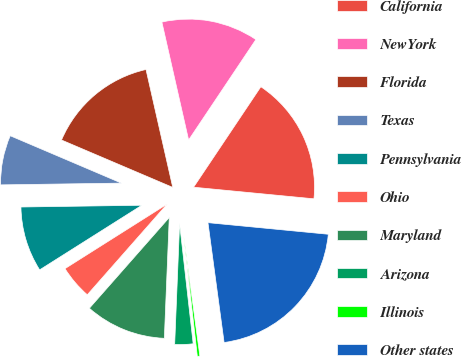Convert chart to OTSL. <chart><loc_0><loc_0><loc_500><loc_500><pie_chart><fcel>California<fcel>NewYork<fcel>Florida<fcel>Texas<fcel>Pennsylvania<fcel>Ohio<fcel>Maryland<fcel>Arizona<fcel>Illinois<fcel>Other states<nl><fcel>17.14%<fcel>12.94%<fcel>15.04%<fcel>6.64%<fcel>8.74%<fcel>4.54%<fcel>10.84%<fcel>2.44%<fcel>0.34%<fcel>21.34%<nl></chart> 